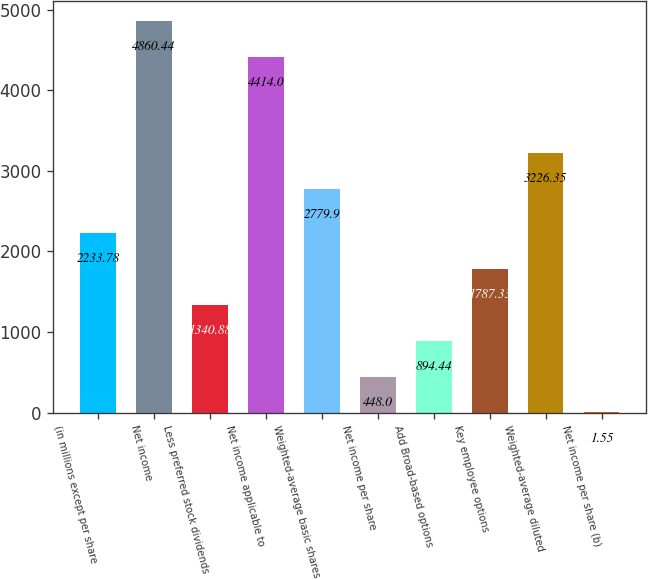Convert chart. <chart><loc_0><loc_0><loc_500><loc_500><bar_chart><fcel>(in millions except per share<fcel>Net income<fcel>Less preferred stock dividends<fcel>Net income applicable to<fcel>Weighted-average basic shares<fcel>Net income per share<fcel>Add Broad-based options<fcel>Key employee options<fcel>Weighted-average diluted<fcel>Net income per share (b)<nl><fcel>2233.78<fcel>4860.44<fcel>1340.88<fcel>4414<fcel>2779.9<fcel>448<fcel>894.44<fcel>1787.33<fcel>3226.35<fcel>1.55<nl></chart> 